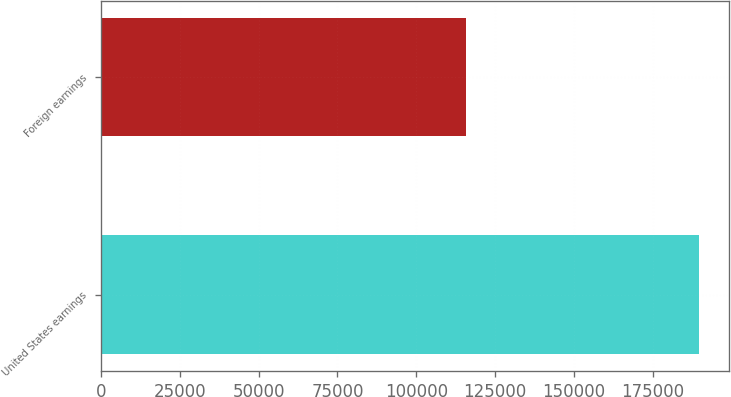Convert chart to OTSL. <chart><loc_0><loc_0><loc_500><loc_500><bar_chart><fcel>United States earnings<fcel>Foreign earnings<nl><fcel>189545<fcel>115742<nl></chart> 